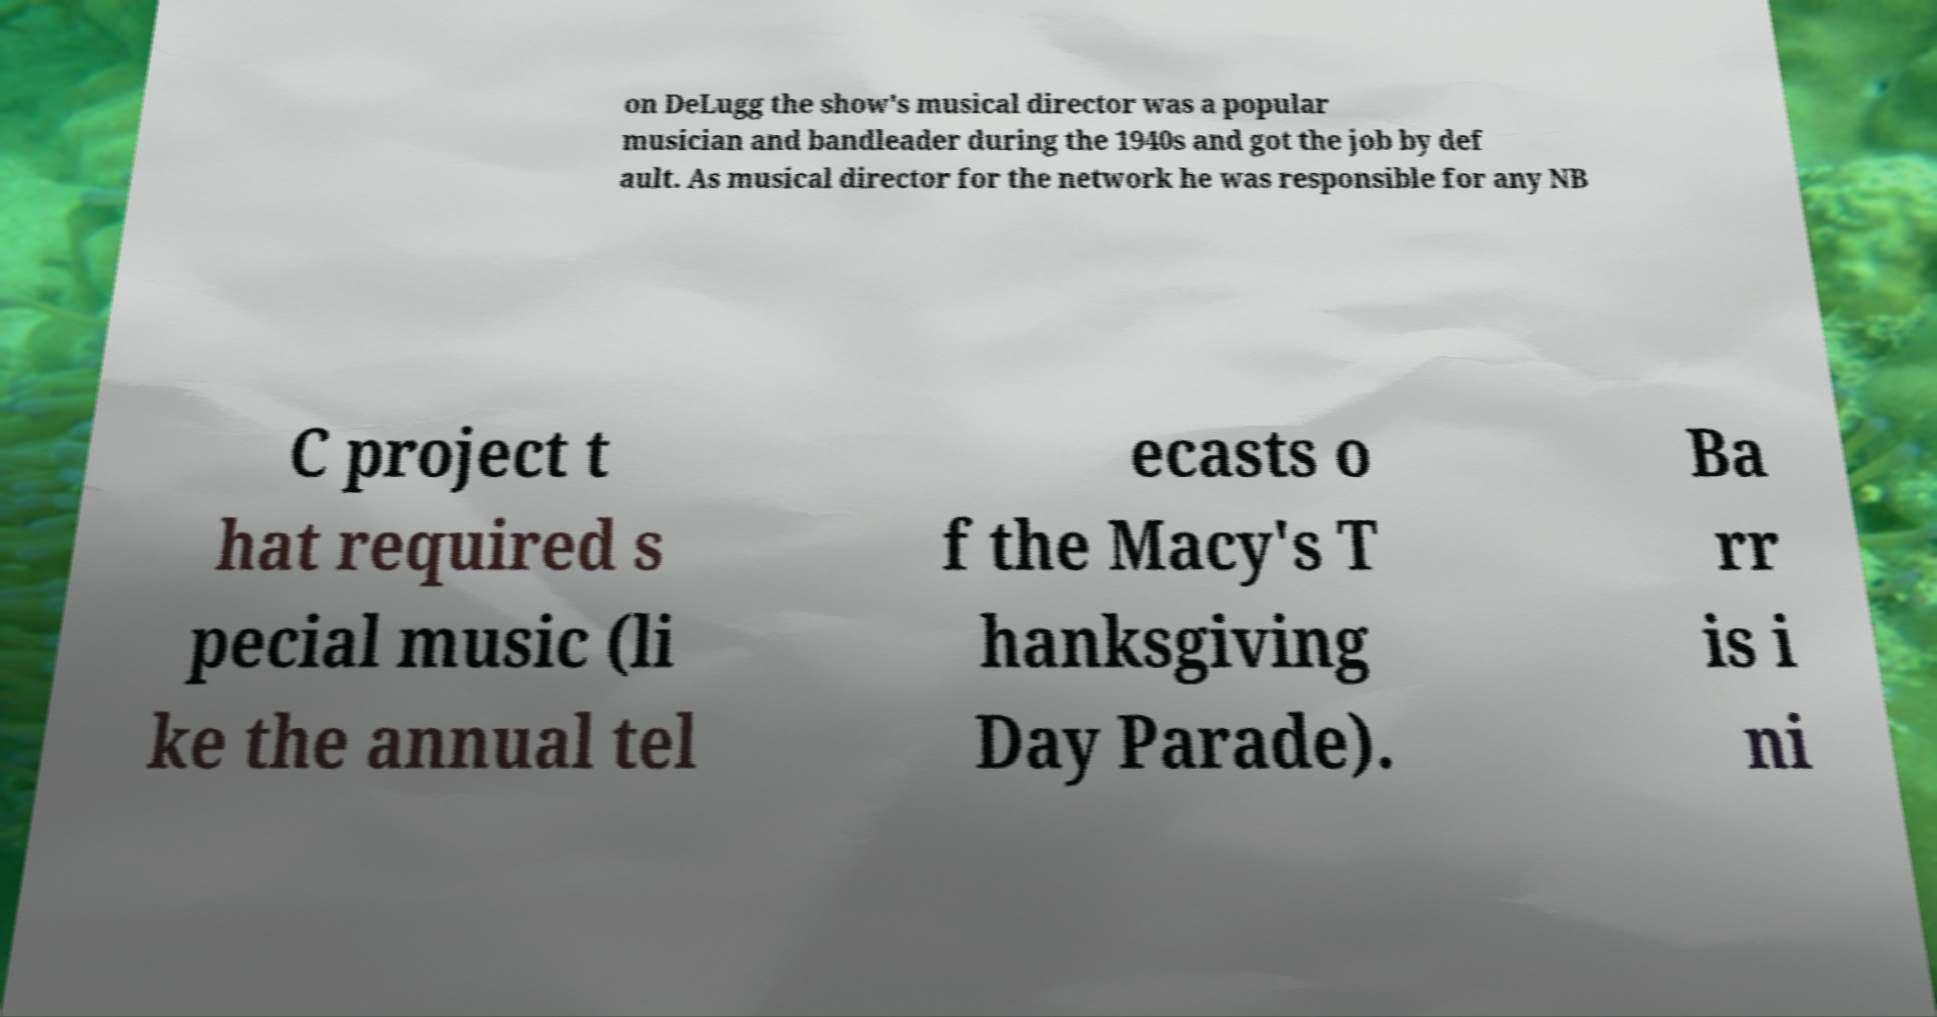Can you accurately transcribe the text from the provided image for me? on DeLugg the show's musical director was a popular musician and bandleader during the 1940s and got the job by def ault. As musical director for the network he was responsible for any NB C project t hat required s pecial music (li ke the annual tel ecasts o f the Macy's T hanksgiving Day Parade). Ba rr is i ni 